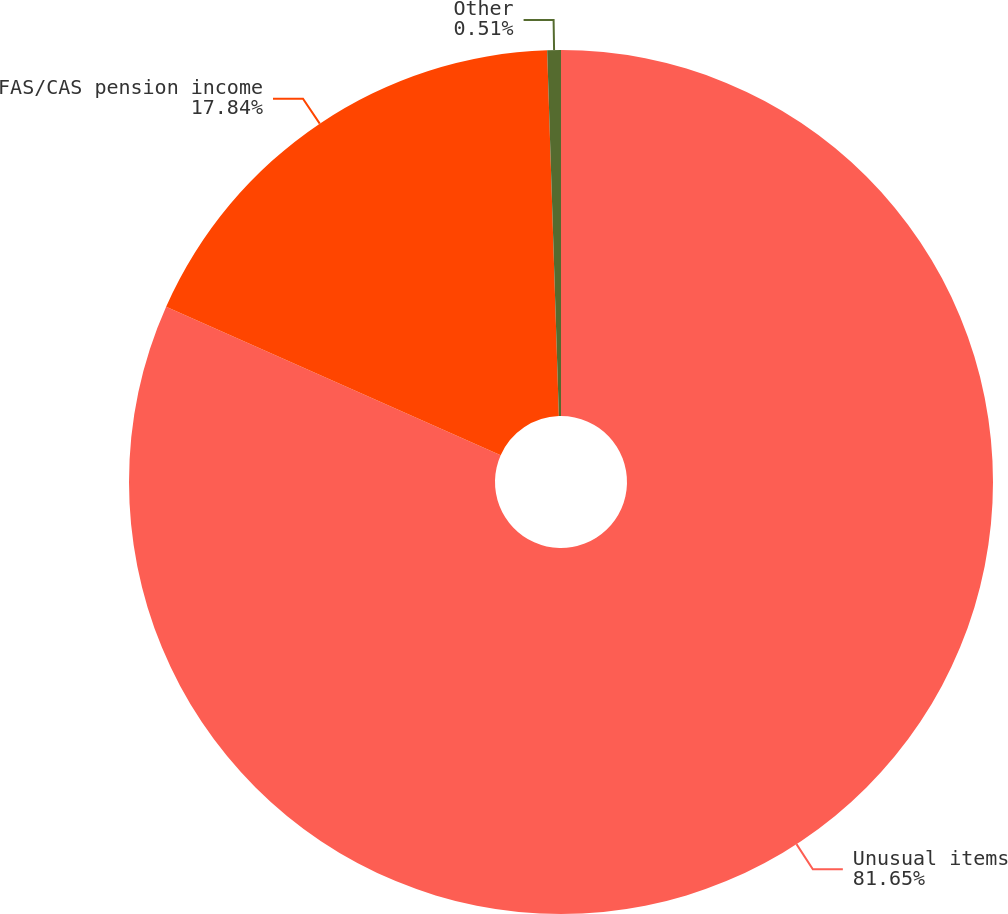<chart> <loc_0><loc_0><loc_500><loc_500><pie_chart><fcel>Unusual items<fcel>FAS/CAS pension income<fcel>Other<nl><fcel>81.64%<fcel>17.84%<fcel>0.51%<nl></chart> 